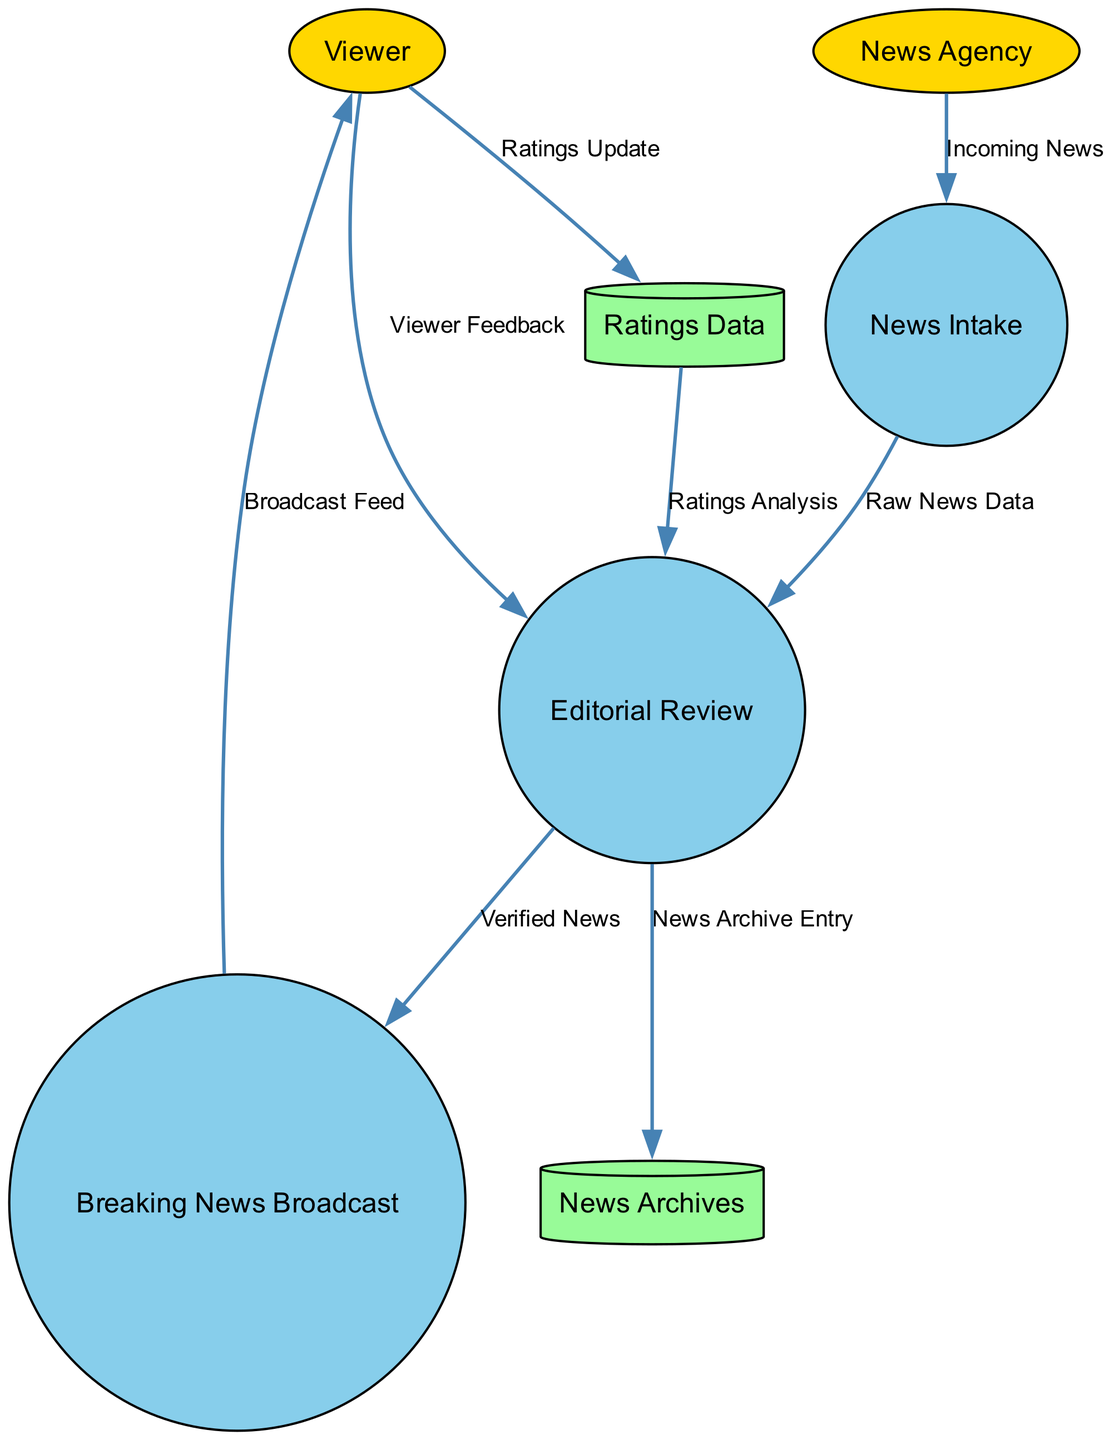What is the first process in the diagram? The first process is "News Intake," which is the initial point where incoming news from the News Agency is processed.
Answer: News Intake How many external entities are represented in the diagram? There are two external entities shown in the diagram: Viewer and News Agency.
Answer: 2 What type of data flow connects the News Agency to the News Intake process? The data flow is labeled "Incoming News," indicating that news information is coming from the News Agency to the News Intake.
Answer: Incoming News Which process produces the Verified News? The Verified News is produced by the process known as "Editorial Review," where the raw news data is evaluated and verified before broadcasting.
Answer: Editorial Review What data store is used for storing viewer feedback? The diagram does not specify a data store for viewer feedback directly; instead, the viewer feedback flows to the "Editorial Review" process.
Answer: None What type of information does the Ratings Analysis process use? The Ratings Analysis process uses information from the "Ratings Data" data store, which contains viewer ratings updates for analysis.
Answer: Ratings Data What is the output of the Breaking News Broadcast process? The output of the Breaking News Broadcast process is a "Broadcast Feed" that is delivered to the Viewer.
Answer: Broadcast Feed What connects Viewer Feedback to the Editorial Review process? The connection is made through the "Viewer Feedback" data flow, indicating that viewer responses are taken into account during the editorial review.
Answer: Viewer Feedback What is the relationship between the Editorial Review process and the News Archives data store? The Editorial Review process sends an entry labeled "News Archive Entry" to the News Archives, indicating that verified news is stored for future reference.
Answer: News Archive Entry Which data flow updates the Ratings Data? The data flow labeled "Ratings Update," which comes from the Viewer, updates the Ratings Data to reflect feedback and viewer engagement levels.
Answer: Ratings Update 